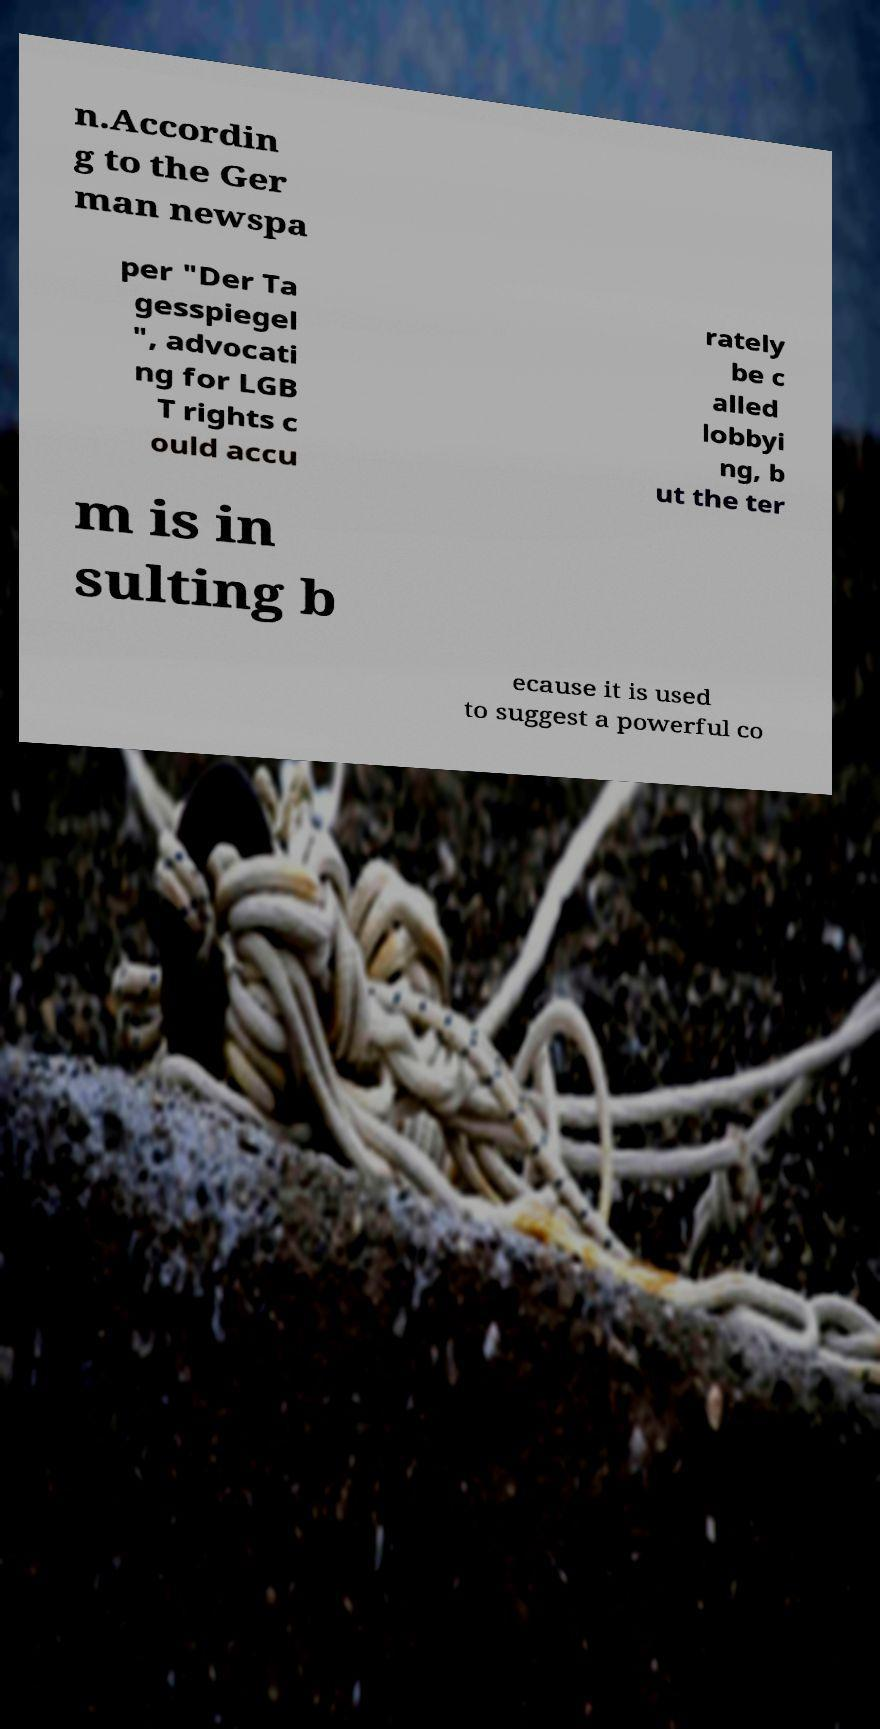There's text embedded in this image that I need extracted. Can you transcribe it verbatim? n.Accordin g to the Ger man newspa per "Der Ta gesspiegel ", advocati ng for LGB T rights c ould accu rately be c alled lobbyi ng, b ut the ter m is in sulting b ecause it is used to suggest a powerful co 